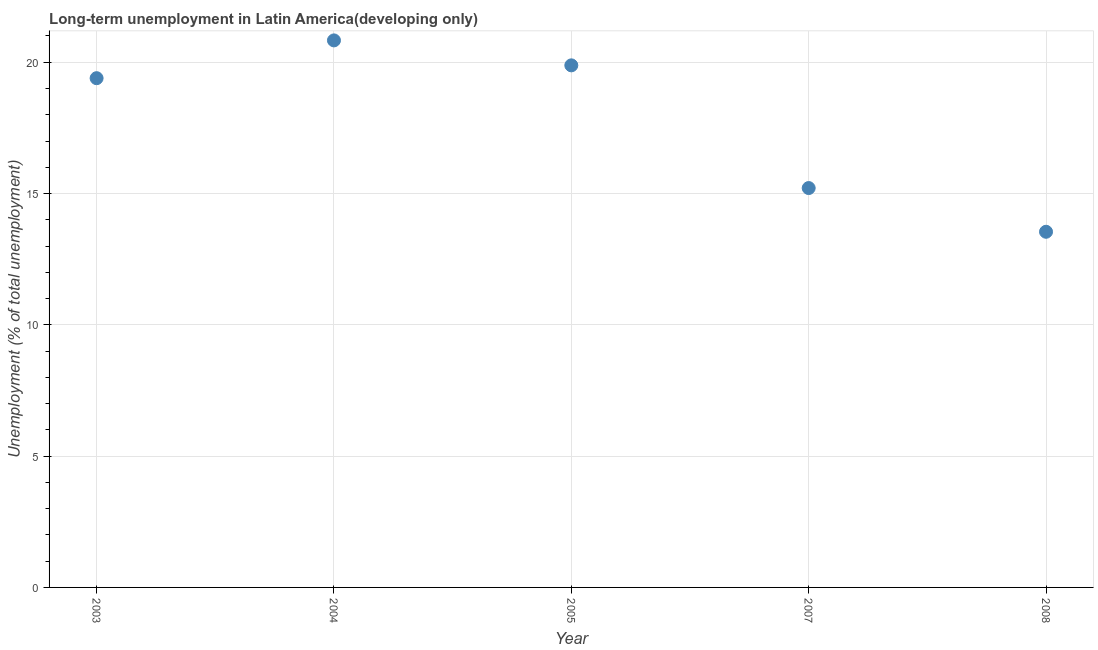What is the long-term unemployment in 2003?
Ensure brevity in your answer.  19.39. Across all years, what is the maximum long-term unemployment?
Your answer should be very brief. 20.83. Across all years, what is the minimum long-term unemployment?
Your response must be concise. 13.54. In which year was the long-term unemployment maximum?
Your answer should be compact. 2004. What is the sum of the long-term unemployment?
Ensure brevity in your answer.  88.86. What is the difference between the long-term unemployment in 2007 and 2008?
Keep it short and to the point. 1.66. What is the average long-term unemployment per year?
Your response must be concise. 17.77. What is the median long-term unemployment?
Give a very brief answer. 19.39. Do a majority of the years between 2005 and 2008 (inclusive) have long-term unemployment greater than 19 %?
Keep it short and to the point. No. What is the ratio of the long-term unemployment in 2004 to that in 2005?
Offer a terse response. 1.05. Is the long-term unemployment in 2003 less than that in 2007?
Offer a very short reply. No. Is the difference between the long-term unemployment in 2007 and 2008 greater than the difference between any two years?
Keep it short and to the point. No. What is the difference between the highest and the second highest long-term unemployment?
Ensure brevity in your answer.  0.95. Is the sum of the long-term unemployment in 2004 and 2007 greater than the maximum long-term unemployment across all years?
Provide a succinct answer. Yes. What is the difference between the highest and the lowest long-term unemployment?
Ensure brevity in your answer.  7.29. In how many years, is the long-term unemployment greater than the average long-term unemployment taken over all years?
Provide a succinct answer. 3. Does the long-term unemployment monotonically increase over the years?
Make the answer very short. No. How many years are there in the graph?
Your answer should be very brief. 5. What is the difference between two consecutive major ticks on the Y-axis?
Keep it short and to the point. 5. Does the graph contain grids?
Make the answer very short. Yes. What is the title of the graph?
Your answer should be compact. Long-term unemployment in Latin America(developing only). What is the label or title of the Y-axis?
Provide a short and direct response. Unemployment (% of total unemployment). What is the Unemployment (% of total unemployment) in 2003?
Your response must be concise. 19.39. What is the Unemployment (% of total unemployment) in 2004?
Provide a short and direct response. 20.83. What is the Unemployment (% of total unemployment) in 2005?
Your answer should be very brief. 19.88. What is the Unemployment (% of total unemployment) in 2007?
Ensure brevity in your answer.  15.21. What is the Unemployment (% of total unemployment) in 2008?
Your response must be concise. 13.54. What is the difference between the Unemployment (% of total unemployment) in 2003 and 2004?
Your answer should be very brief. -1.44. What is the difference between the Unemployment (% of total unemployment) in 2003 and 2005?
Your response must be concise. -0.49. What is the difference between the Unemployment (% of total unemployment) in 2003 and 2007?
Keep it short and to the point. 4.18. What is the difference between the Unemployment (% of total unemployment) in 2003 and 2008?
Offer a terse response. 5.85. What is the difference between the Unemployment (% of total unemployment) in 2004 and 2005?
Offer a very short reply. 0.95. What is the difference between the Unemployment (% of total unemployment) in 2004 and 2007?
Your answer should be compact. 5.62. What is the difference between the Unemployment (% of total unemployment) in 2004 and 2008?
Your answer should be compact. 7.29. What is the difference between the Unemployment (% of total unemployment) in 2005 and 2007?
Keep it short and to the point. 4.67. What is the difference between the Unemployment (% of total unemployment) in 2005 and 2008?
Provide a short and direct response. 6.34. What is the difference between the Unemployment (% of total unemployment) in 2007 and 2008?
Provide a succinct answer. 1.66. What is the ratio of the Unemployment (% of total unemployment) in 2003 to that in 2007?
Provide a succinct answer. 1.27. What is the ratio of the Unemployment (% of total unemployment) in 2003 to that in 2008?
Your response must be concise. 1.43. What is the ratio of the Unemployment (% of total unemployment) in 2004 to that in 2005?
Your answer should be compact. 1.05. What is the ratio of the Unemployment (% of total unemployment) in 2004 to that in 2007?
Offer a terse response. 1.37. What is the ratio of the Unemployment (% of total unemployment) in 2004 to that in 2008?
Offer a terse response. 1.54. What is the ratio of the Unemployment (% of total unemployment) in 2005 to that in 2007?
Give a very brief answer. 1.31. What is the ratio of the Unemployment (% of total unemployment) in 2005 to that in 2008?
Provide a short and direct response. 1.47. What is the ratio of the Unemployment (% of total unemployment) in 2007 to that in 2008?
Offer a very short reply. 1.12. 